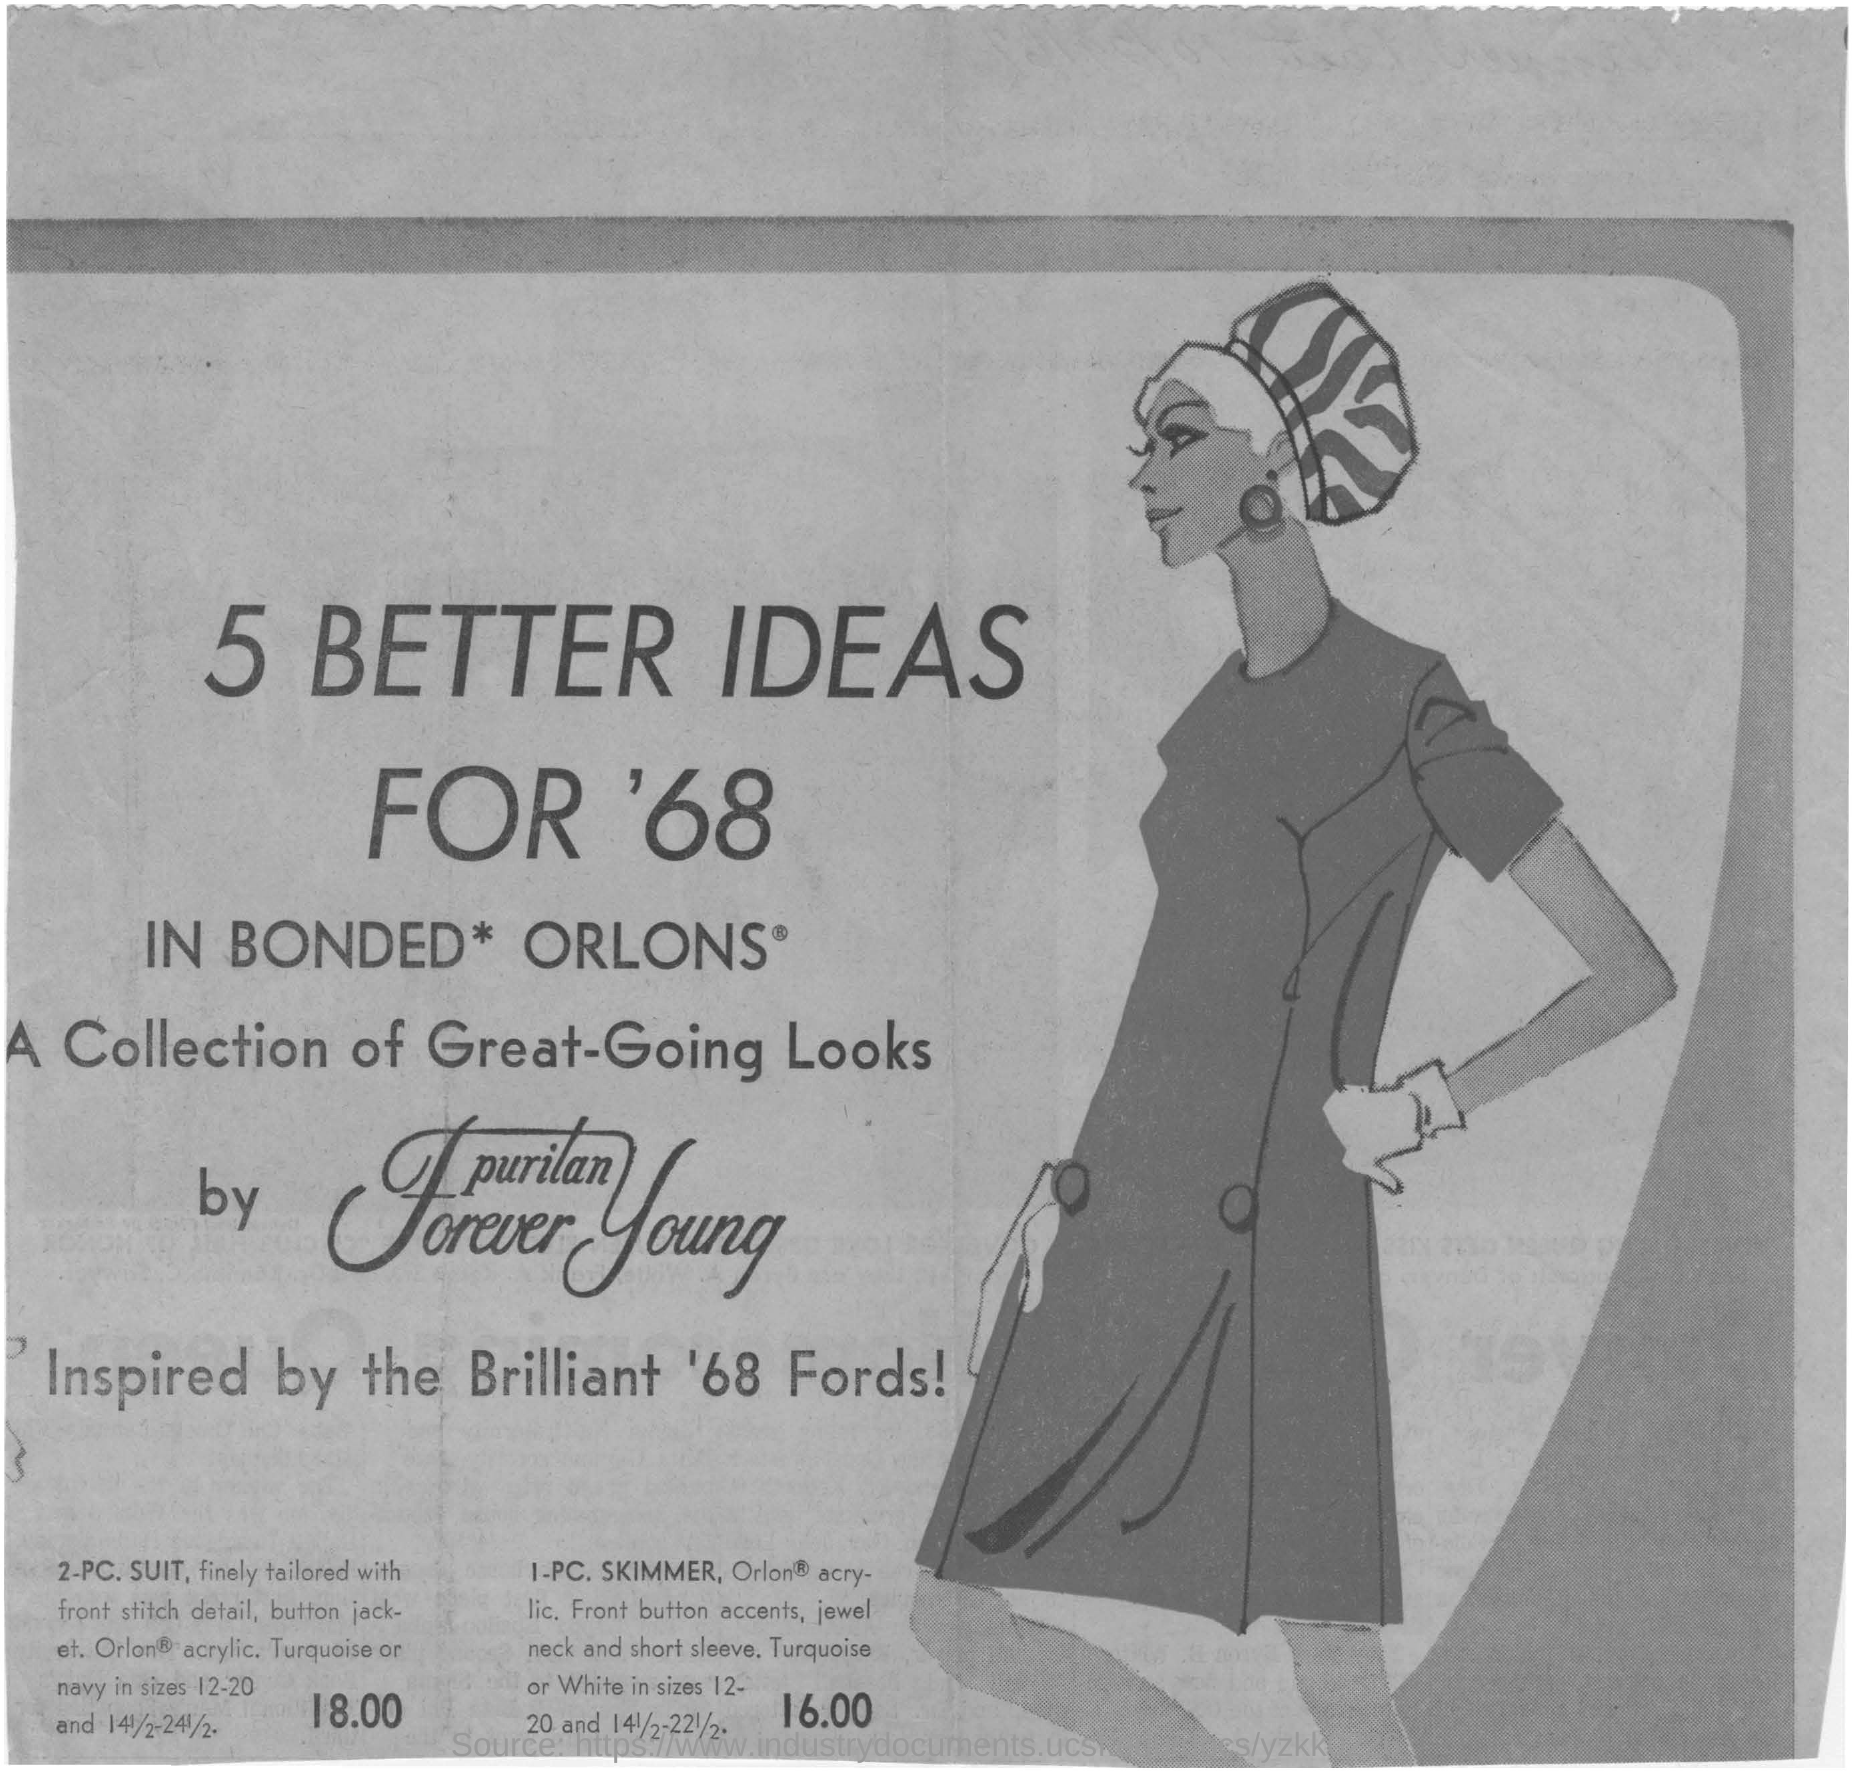5 BETTER IDEAS FOR what?
Offer a very short reply. For '68. By whom is this document inspired?
Your response must be concise. The brilliant '68 fords!. What are the sizes of Turquoise or navy?
Your response must be concise. 12-20 and 141/2-241/2. 